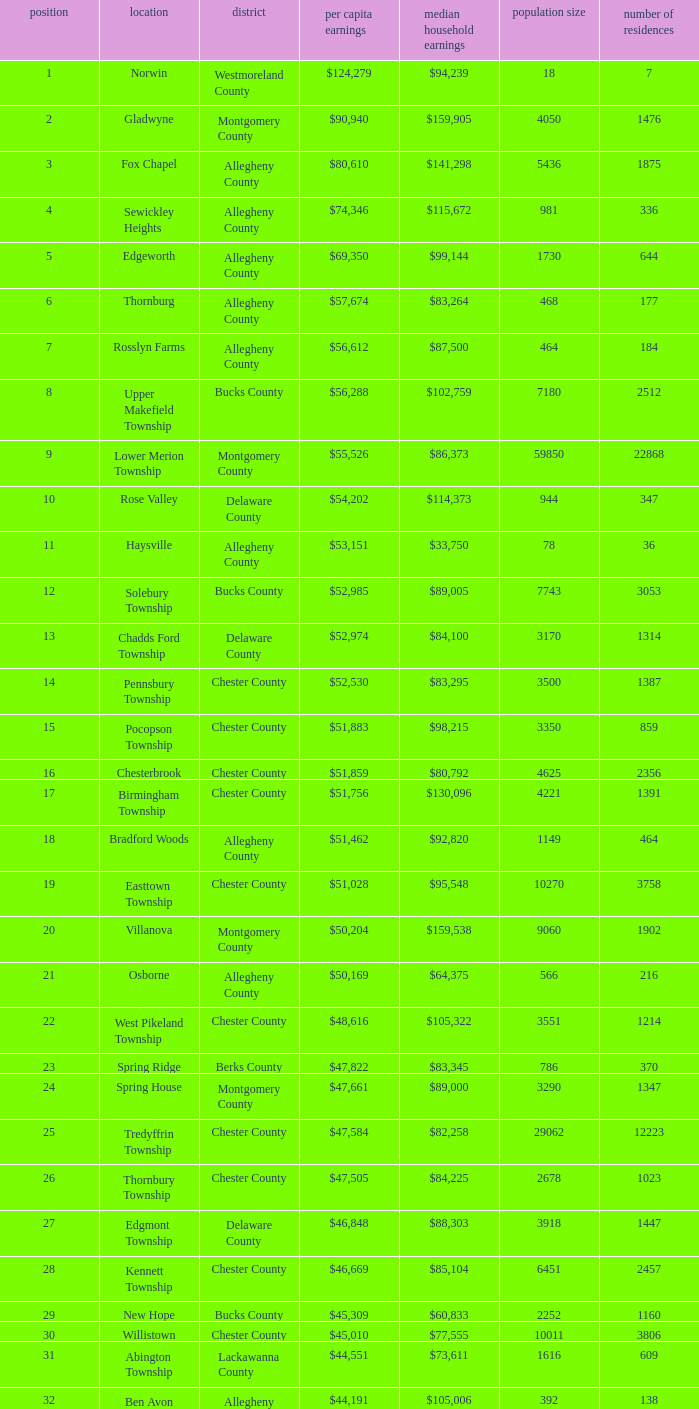What is the median household income for Woodside? $121,151. 